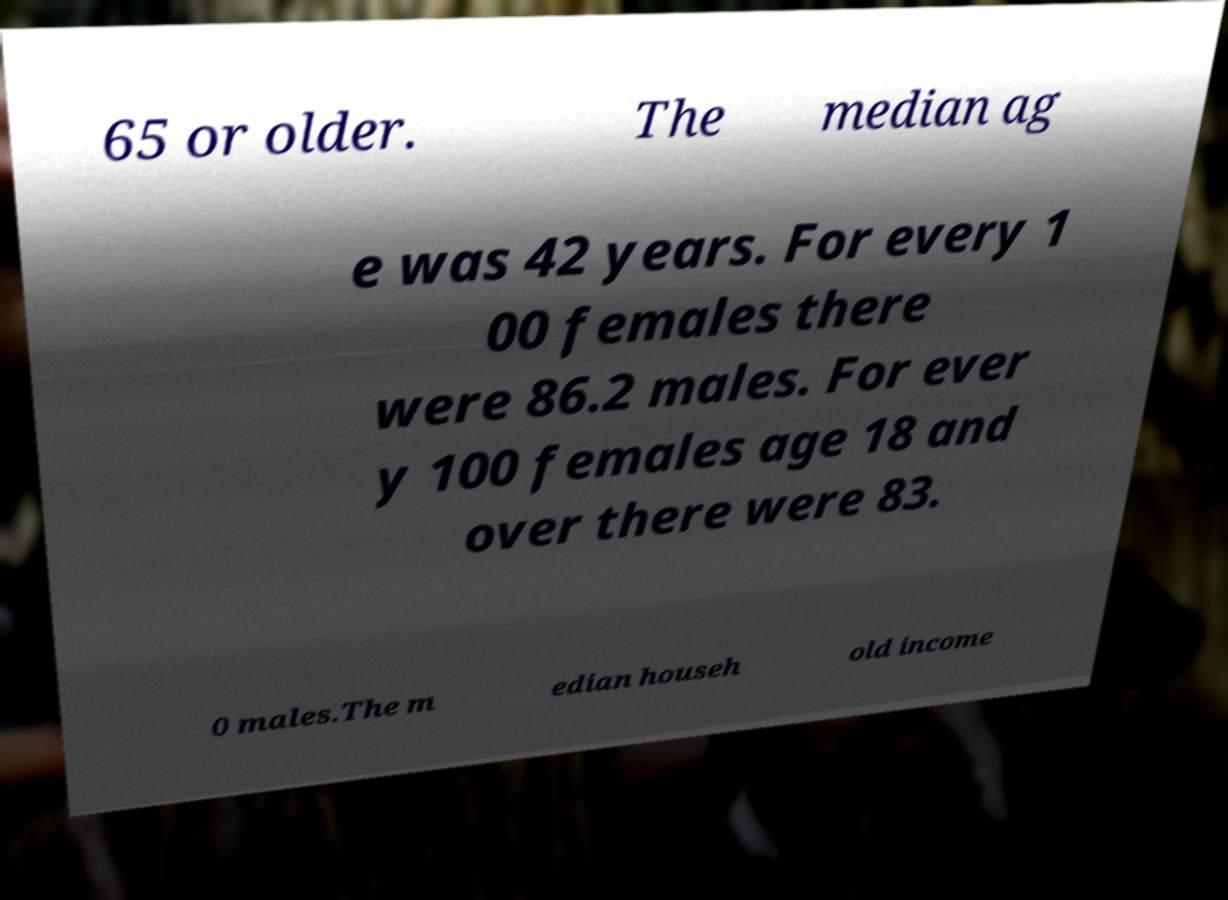There's text embedded in this image that I need extracted. Can you transcribe it verbatim? 65 or older. The median ag e was 42 years. For every 1 00 females there were 86.2 males. For ever y 100 females age 18 and over there were 83. 0 males.The m edian househ old income 